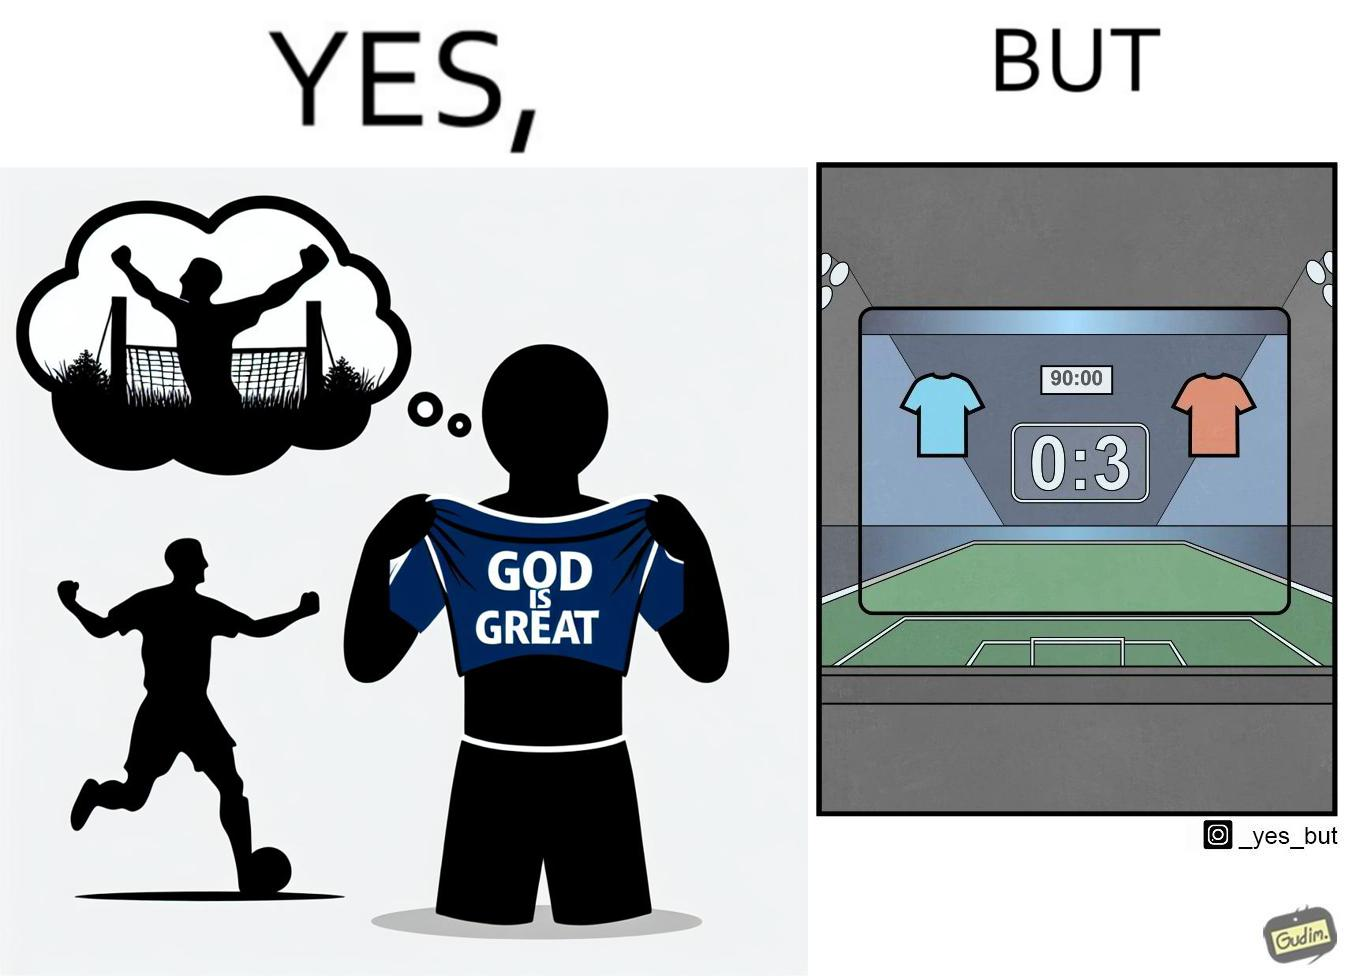Compare the left and right sides of this image. In the left part of the image: The image shows a football player wearing a t-shirt under his blue jersey that says "GOD IS GREAT". The player is thinking that he will celebrate by showing the inner t-shirt with the text when he scores a goal. In the right part of the image: The image shows the results of a football match after the 90 minutes are over. It shows that the team wearing the red jersey scored 3 goals whereas the team with blue jersey scored 0 goals. The red team has won the match. 